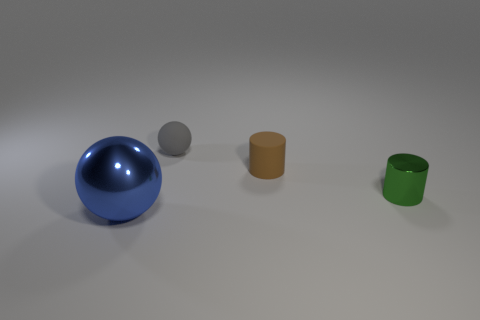There is a small cylinder that is on the right side of the small cylinder behind the small green metal object; what number of matte cylinders are in front of it?
Provide a succinct answer. 0. How many brown metallic blocks are there?
Give a very brief answer. 0. Are there fewer tiny metal objects that are left of the large metal sphere than brown matte things that are behind the small gray ball?
Ensure brevity in your answer.  No. Are there fewer small gray spheres that are in front of the blue metal thing than large purple shiny things?
Ensure brevity in your answer.  No. What material is the sphere that is left of the matte object behind the tiny cylinder to the left of the tiny green thing?
Your answer should be very brief. Metal. How many objects are rubber things that are behind the matte cylinder or objects in front of the small green thing?
Make the answer very short. 2. There is a gray thing that is the same shape as the blue metallic object; what is it made of?
Your response must be concise. Rubber. How many metal objects are either cylinders or big balls?
Provide a succinct answer. 2. There is another object that is the same material as the gray object; what shape is it?
Offer a terse response. Cylinder. How many big blue rubber things are the same shape as the gray matte object?
Make the answer very short. 0. 